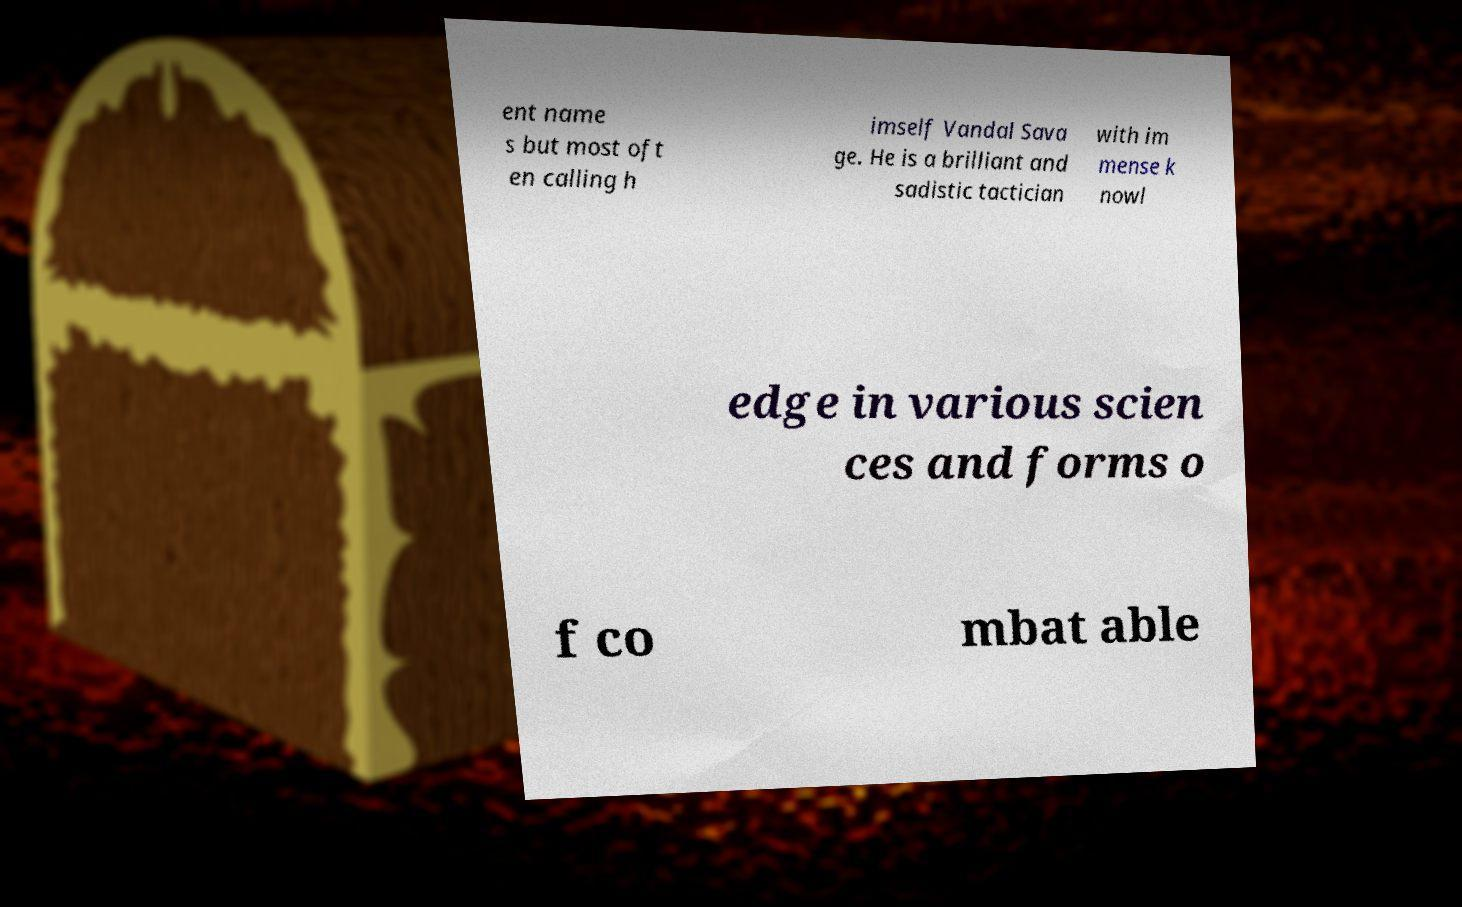Please identify and transcribe the text found in this image. ent name s but most oft en calling h imself Vandal Sava ge. He is a brilliant and sadistic tactician with im mense k nowl edge in various scien ces and forms o f co mbat able 